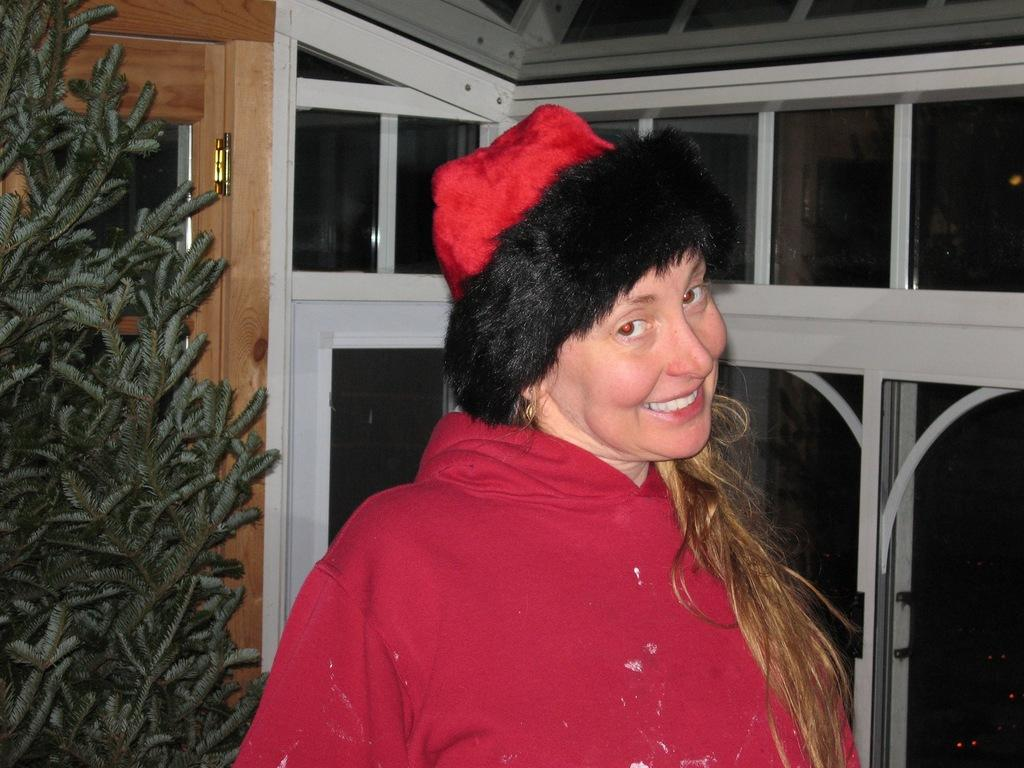Who is the main subject in the image? There is a lady in the center of the image. What can be seen in the background of the image? There are windows in the image. Are there any other objects or living organisms in the image? Yes, there is a plant in the image. What type of hook can be seen hanging from the ceiling in the image? There is no hook visible in the image; it only features a lady, windows, and a plant. 